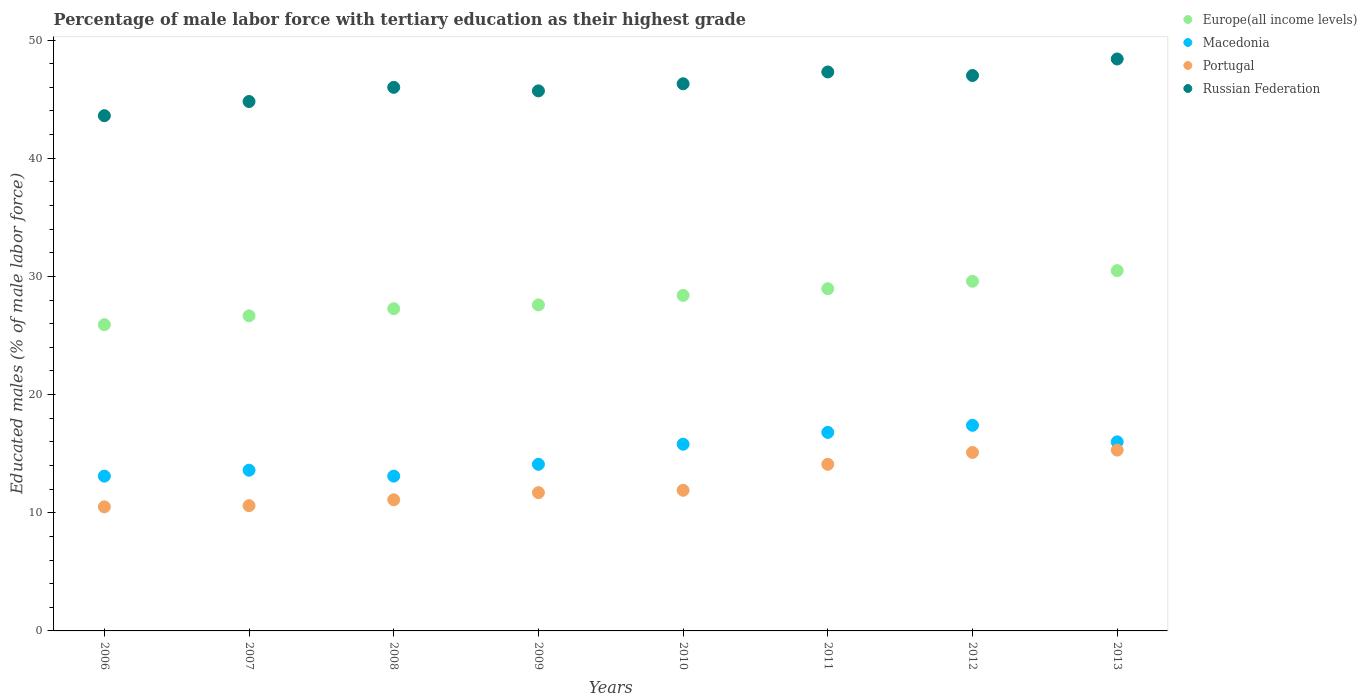What is the percentage of male labor force with tertiary education in Portugal in 2010?
Offer a very short reply. 11.9. Across all years, what is the maximum percentage of male labor force with tertiary education in Portugal?
Your response must be concise. 15.3. Across all years, what is the minimum percentage of male labor force with tertiary education in Europe(all income levels)?
Ensure brevity in your answer.  25.91. What is the total percentage of male labor force with tertiary education in Russian Federation in the graph?
Your answer should be very brief. 369.1. What is the difference between the percentage of male labor force with tertiary education in Europe(all income levels) in 2011 and the percentage of male labor force with tertiary education in Russian Federation in 2012?
Offer a very short reply. -18.04. What is the average percentage of male labor force with tertiary education in Europe(all income levels) per year?
Provide a succinct answer. 28.11. In the year 2010, what is the difference between the percentage of male labor force with tertiary education in Macedonia and percentage of male labor force with tertiary education in Portugal?
Offer a very short reply. 3.9. In how many years, is the percentage of male labor force with tertiary education in Europe(all income levels) greater than 10 %?
Provide a succinct answer. 8. What is the ratio of the percentage of male labor force with tertiary education in Russian Federation in 2006 to that in 2007?
Your response must be concise. 0.97. What is the difference between the highest and the second highest percentage of male labor force with tertiary education in Russian Federation?
Provide a succinct answer. 1.1. What is the difference between the highest and the lowest percentage of male labor force with tertiary education in Europe(all income levels)?
Provide a short and direct response. 4.58. Is the sum of the percentage of male labor force with tertiary education in Russian Federation in 2010 and 2011 greater than the maximum percentage of male labor force with tertiary education in Portugal across all years?
Provide a succinct answer. Yes. Is it the case that in every year, the sum of the percentage of male labor force with tertiary education in Macedonia and percentage of male labor force with tertiary education in Europe(all income levels)  is greater than the sum of percentage of male labor force with tertiary education in Portugal and percentage of male labor force with tertiary education in Russian Federation?
Provide a short and direct response. Yes. Is the percentage of male labor force with tertiary education in Russian Federation strictly less than the percentage of male labor force with tertiary education in Macedonia over the years?
Offer a very short reply. No. How many dotlines are there?
Offer a very short reply. 4. What is the difference between two consecutive major ticks on the Y-axis?
Provide a short and direct response. 10. Does the graph contain any zero values?
Keep it short and to the point. No. Where does the legend appear in the graph?
Ensure brevity in your answer.  Top right. What is the title of the graph?
Your answer should be compact. Percentage of male labor force with tertiary education as their highest grade. What is the label or title of the X-axis?
Provide a succinct answer. Years. What is the label or title of the Y-axis?
Give a very brief answer. Educated males (% of male labor force). What is the Educated males (% of male labor force) in Europe(all income levels) in 2006?
Offer a terse response. 25.91. What is the Educated males (% of male labor force) in Macedonia in 2006?
Make the answer very short. 13.1. What is the Educated males (% of male labor force) of Portugal in 2006?
Ensure brevity in your answer.  10.5. What is the Educated males (% of male labor force) of Russian Federation in 2006?
Your answer should be compact. 43.6. What is the Educated males (% of male labor force) of Europe(all income levels) in 2007?
Ensure brevity in your answer.  26.66. What is the Educated males (% of male labor force) of Macedonia in 2007?
Keep it short and to the point. 13.6. What is the Educated males (% of male labor force) in Portugal in 2007?
Provide a succinct answer. 10.6. What is the Educated males (% of male labor force) in Russian Federation in 2007?
Offer a terse response. 44.8. What is the Educated males (% of male labor force) in Europe(all income levels) in 2008?
Provide a succinct answer. 27.27. What is the Educated males (% of male labor force) of Macedonia in 2008?
Your answer should be very brief. 13.1. What is the Educated males (% of male labor force) of Portugal in 2008?
Your response must be concise. 11.1. What is the Educated males (% of male labor force) in Europe(all income levels) in 2009?
Keep it short and to the point. 27.59. What is the Educated males (% of male labor force) of Macedonia in 2009?
Provide a short and direct response. 14.1. What is the Educated males (% of male labor force) in Portugal in 2009?
Provide a short and direct response. 11.7. What is the Educated males (% of male labor force) of Russian Federation in 2009?
Offer a very short reply. 45.7. What is the Educated males (% of male labor force) of Europe(all income levels) in 2010?
Ensure brevity in your answer.  28.39. What is the Educated males (% of male labor force) in Macedonia in 2010?
Make the answer very short. 15.8. What is the Educated males (% of male labor force) of Portugal in 2010?
Make the answer very short. 11.9. What is the Educated males (% of male labor force) of Russian Federation in 2010?
Provide a short and direct response. 46.3. What is the Educated males (% of male labor force) in Europe(all income levels) in 2011?
Your answer should be very brief. 28.96. What is the Educated males (% of male labor force) in Macedonia in 2011?
Provide a succinct answer. 16.8. What is the Educated males (% of male labor force) in Portugal in 2011?
Your answer should be compact. 14.1. What is the Educated males (% of male labor force) in Russian Federation in 2011?
Give a very brief answer. 47.3. What is the Educated males (% of male labor force) of Europe(all income levels) in 2012?
Offer a terse response. 29.59. What is the Educated males (% of male labor force) in Macedonia in 2012?
Your answer should be compact. 17.4. What is the Educated males (% of male labor force) in Portugal in 2012?
Offer a very short reply. 15.1. What is the Educated males (% of male labor force) in Russian Federation in 2012?
Provide a short and direct response. 47. What is the Educated males (% of male labor force) in Europe(all income levels) in 2013?
Offer a terse response. 30.49. What is the Educated males (% of male labor force) in Macedonia in 2013?
Your response must be concise. 16. What is the Educated males (% of male labor force) of Portugal in 2013?
Your answer should be very brief. 15.3. What is the Educated males (% of male labor force) of Russian Federation in 2013?
Your answer should be compact. 48.4. Across all years, what is the maximum Educated males (% of male labor force) in Europe(all income levels)?
Your answer should be compact. 30.49. Across all years, what is the maximum Educated males (% of male labor force) in Macedonia?
Your response must be concise. 17.4. Across all years, what is the maximum Educated males (% of male labor force) of Portugal?
Make the answer very short. 15.3. Across all years, what is the maximum Educated males (% of male labor force) of Russian Federation?
Make the answer very short. 48.4. Across all years, what is the minimum Educated males (% of male labor force) in Europe(all income levels)?
Ensure brevity in your answer.  25.91. Across all years, what is the minimum Educated males (% of male labor force) of Macedonia?
Provide a short and direct response. 13.1. Across all years, what is the minimum Educated males (% of male labor force) in Russian Federation?
Offer a terse response. 43.6. What is the total Educated males (% of male labor force) of Europe(all income levels) in the graph?
Make the answer very short. 224.86. What is the total Educated males (% of male labor force) in Macedonia in the graph?
Your response must be concise. 119.9. What is the total Educated males (% of male labor force) of Portugal in the graph?
Ensure brevity in your answer.  100.3. What is the total Educated males (% of male labor force) in Russian Federation in the graph?
Your answer should be compact. 369.1. What is the difference between the Educated males (% of male labor force) of Europe(all income levels) in 2006 and that in 2007?
Your answer should be compact. -0.75. What is the difference between the Educated males (% of male labor force) of Portugal in 2006 and that in 2007?
Ensure brevity in your answer.  -0.1. What is the difference between the Educated males (% of male labor force) in Russian Federation in 2006 and that in 2007?
Your response must be concise. -1.2. What is the difference between the Educated males (% of male labor force) in Europe(all income levels) in 2006 and that in 2008?
Your answer should be very brief. -1.35. What is the difference between the Educated males (% of male labor force) of Macedonia in 2006 and that in 2008?
Provide a succinct answer. 0. What is the difference between the Educated males (% of male labor force) in Portugal in 2006 and that in 2008?
Your answer should be very brief. -0.6. What is the difference between the Educated males (% of male labor force) in Europe(all income levels) in 2006 and that in 2009?
Your answer should be very brief. -1.67. What is the difference between the Educated males (% of male labor force) of Macedonia in 2006 and that in 2009?
Offer a terse response. -1. What is the difference between the Educated males (% of male labor force) of Portugal in 2006 and that in 2009?
Your answer should be very brief. -1.2. What is the difference between the Educated males (% of male labor force) of Europe(all income levels) in 2006 and that in 2010?
Provide a succinct answer. -2.48. What is the difference between the Educated males (% of male labor force) of Macedonia in 2006 and that in 2010?
Your answer should be compact. -2.7. What is the difference between the Educated males (% of male labor force) in Portugal in 2006 and that in 2010?
Make the answer very short. -1.4. What is the difference between the Educated males (% of male labor force) in Europe(all income levels) in 2006 and that in 2011?
Provide a short and direct response. -3.04. What is the difference between the Educated males (% of male labor force) of Portugal in 2006 and that in 2011?
Provide a succinct answer. -3.6. What is the difference between the Educated males (% of male labor force) in Russian Federation in 2006 and that in 2011?
Provide a short and direct response. -3.7. What is the difference between the Educated males (% of male labor force) of Europe(all income levels) in 2006 and that in 2012?
Keep it short and to the point. -3.68. What is the difference between the Educated males (% of male labor force) in Macedonia in 2006 and that in 2012?
Provide a succinct answer. -4.3. What is the difference between the Educated males (% of male labor force) of Portugal in 2006 and that in 2012?
Your answer should be very brief. -4.6. What is the difference between the Educated males (% of male labor force) in Russian Federation in 2006 and that in 2012?
Your answer should be compact. -3.4. What is the difference between the Educated males (% of male labor force) in Europe(all income levels) in 2006 and that in 2013?
Give a very brief answer. -4.58. What is the difference between the Educated males (% of male labor force) in Macedonia in 2006 and that in 2013?
Keep it short and to the point. -2.9. What is the difference between the Educated males (% of male labor force) of Europe(all income levels) in 2007 and that in 2008?
Your answer should be compact. -0.6. What is the difference between the Educated males (% of male labor force) in Macedonia in 2007 and that in 2008?
Your response must be concise. 0.5. What is the difference between the Educated males (% of male labor force) in Europe(all income levels) in 2007 and that in 2009?
Ensure brevity in your answer.  -0.92. What is the difference between the Educated males (% of male labor force) in Macedonia in 2007 and that in 2009?
Your answer should be very brief. -0.5. What is the difference between the Educated males (% of male labor force) of Portugal in 2007 and that in 2009?
Offer a very short reply. -1.1. What is the difference between the Educated males (% of male labor force) in Europe(all income levels) in 2007 and that in 2010?
Ensure brevity in your answer.  -1.73. What is the difference between the Educated males (% of male labor force) in Macedonia in 2007 and that in 2010?
Your response must be concise. -2.2. What is the difference between the Educated males (% of male labor force) of Europe(all income levels) in 2007 and that in 2011?
Ensure brevity in your answer.  -2.29. What is the difference between the Educated males (% of male labor force) of Macedonia in 2007 and that in 2011?
Your answer should be compact. -3.2. What is the difference between the Educated males (% of male labor force) in Europe(all income levels) in 2007 and that in 2012?
Your answer should be very brief. -2.93. What is the difference between the Educated males (% of male labor force) of Macedonia in 2007 and that in 2012?
Provide a short and direct response. -3.8. What is the difference between the Educated males (% of male labor force) in Europe(all income levels) in 2007 and that in 2013?
Give a very brief answer. -3.82. What is the difference between the Educated males (% of male labor force) of Macedonia in 2007 and that in 2013?
Your answer should be very brief. -2.4. What is the difference between the Educated males (% of male labor force) in Europe(all income levels) in 2008 and that in 2009?
Provide a short and direct response. -0.32. What is the difference between the Educated males (% of male labor force) of Macedonia in 2008 and that in 2009?
Ensure brevity in your answer.  -1. What is the difference between the Educated males (% of male labor force) in Europe(all income levels) in 2008 and that in 2010?
Provide a succinct answer. -1.12. What is the difference between the Educated males (% of male labor force) in Europe(all income levels) in 2008 and that in 2011?
Provide a succinct answer. -1.69. What is the difference between the Educated males (% of male labor force) of Portugal in 2008 and that in 2011?
Your response must be concise. -3. What is the difference between the Educated males (% of male labor force) of Russian Federation in 2008 and that in 2011?
Offer a very short reply. -1.3. What is the difference between the Educated males (% of male labor force) in Europe(all income levels) in 2008 and that in 2012?
Ensure brevity in your answer.  -2.32. What is the difference between the Educated males (% of male labor force) of Macedonia in 2008 and that in 2012?
Your answer should be compact. -4.3. What is the difference between the Educated males (% of male labor force) of Russian Federation in 2008 and that in 2012?
Provide a short and direct response. -1. What is the difference between the Educated males (% of male labor force) in Europe(all income levels) in 2008 and that in 2013?
Make the answer very short. -3.22. What is the difference between the Educated males (% of male labor force) of Macedonia in 2008 and that in 2013?
Make the answer very short. -2.9. What is the difference between the Educated males (% of male labor force) in Portugal in 2008 and that in 2013?
Provide a short and direct response. -4.2. What is the difference between the Educated males (% of male labor force) of Europe(all income levels) in 2009 and that in 2010?
Give a very brief answer. -0.8. What is the difference between the Educated males (% of male labor force) of Macedonia in 2009 and that in 2010?
Provide a short and direct response. -1.7. What is the difference between the Educated males (% of male labor force) in Russian Federation in 2009 and that in 2010?
Provide a short and direct response. -0.6. What is the difference between the Educated males (% of male labor force) of Europe(all income levels) in 2009 and that in 2011?
Offer a very short reply. -1.37. What is the difference between the Educated males (% of male labor force) of Macedonia in 2009 and that in 2011?
Provide a succinct answer. -2.7. What is the difference between the Educated males (% of male labor force) of Europe(all income levels) in 2009 and that in 2012?
Make the answer very short. -2. What is the difference between the Educated males (% of male labor force) of Portugal in 2009 and that in 2012?
Keep it short and to the point. -3.4. What is the difference between the Educated males (% of male labor force) in Europe(all income levels) in 2009 and that in 2013?
Offer a terse response. -2.9. What is the difference between the Educated males (% of male labor force) in Europe(all income levels) in 2010 and that in 2011?
Your answer should be compact. -0.57. What is the difference between the Educated males (% of male labor force) of Portugal in 2010 and that in 2011?
Your answer should be compact. -2.2. What is the difference between the Educated males (% of male labor force) of Russian Federation in 2010 and that in 2011?
Your answer should be very brief. -1. What is the difference between the Educated males (% of male labor force) of Europe(all income levels) in 2010 and that in 2012?
Provide a succinct answer. -1.2. What is the difference between the Educated males (% of male labor force) of Russian Federation in 2010 and that in 2012?
Offer a very short reply. -0.7. What is the difference between the Educated males (% of male labor force) in Europe(all income levels) in 2010 and that in 2013?
Provide a succinct answer. -2.1. What is the difference between the Educated males (% of male labor force) of Portugal in 2010 and that in 2013?
Offer a terse response. -3.4. What is the difference between the Educated males (% of male labor force) of Europe(all income levels) in 2011 and that in 2012?
Give a very brief answer. -0.63. What is the difference between the Educated males (% of male labor force) of Portugal in 2011 and that in 2012?
Your answer should be very brief. -1. What is the difference between the Educated males (% of male labor force) of Europe(all income levels) in 2011 and that in 2013?
Provide a succinct answer. -1.53. What is the difference between the Educated males (% of male labor force) of Russian Federation in 2011 and that in 2013?
Your response must be concise. -1.1. What is the difference between the Educated males (% of male labor force) of Europe(all income levels) in 2012 and that in 2013?
Offer a terse response. -0.9. What is the difference between the Educated males (% of male labor force) of Macedonia in 2012 and that in 2013?
Your answer should be compact. 1.4. What is the difference between the Educated males (% of male labor force) of Portugal in 2012 and that in 2013?
Offer a terse response. -0.2. What is the difference between the Educated males (% of male labor force) in Europe(all income levels) in 2006 and the Educated males (% of male labor force) in Macedonia in 2007?
Ensure brevity in your answer.  12.31. What is the difference between the Educated males (% of male labor force) of Europe(all income levels) in 2006 and the Educated males (% of male labor force) of Portugal in 2007?
Keep it short and to the point. 15.31. What is the difference between the Educated males (% of male labor force) of Europe(all income levels) in 2006 and the Educated males (% of male labor force) of Russian Federation in 2007?
Your answer should be very brief. -18.89. What is the difference between the Educated males (% of male labor force) in Macedonia in 2006 and the Educated males (% of male labor force) in Portugal in 2007?
Keep it short and to the point. 2.5. What is the difference between the Educated males (% of male labor force) in Macedonia in 2006 and the Educated males (% of male labor force) in Russian Federation in 2007?
Provide a short and direct response. -31.7. What is the difference between the Educated males (% of male labor force) in Portugal in 2006 and the Educated males (% of male labor force) in Russian Federation in 2007?
Make the answer very short. -34.3. What is the difference between the Educated males (% of male labor force) of Europe(all income levels) in 2006 and the Educated males (% of male labor force) of Macedonia in 2008?
Give a very brief answer. 12.81. What is the difference between the Educated males (% of male labor force) of Europe(all income levels) in 2006 and the Educated males (% of male labor force) of Portugal in 2008?
Your response must be concise. 14.81. What is the difference between the Educated males (% of male labor force) of Europe(all income levels) in 2006 and the Educated males (% of male labor force) of Russian Federation in 2008?
Your answer should be compact. -20.09. What is the difference between the Educated males (% of male labor force) of Macedonia in 2006 and the Educated males (% of male labor force) of Russian Federation in 2008?
Give a very brief answer. -32.9. What is the difference between the Educated males (% of male labor force) of Portugal in 2006 and the Educated males (% of male labor force) of Russian Federation in 2008?
Your response must be concise. -35.5. What is the difference between the Educated males (% of male labor force) of Europe(all income levels) in 2006 and the Educated males (% of male labor force) of Macedonia in 2009?
Offer a terse response. 11.81. What is the difference between the Educated males (% of male labor force) in Europe(all income levels) in 2006 and the Educated males (% of male labor force) in Portugal in 2009?
Provide a succinct answer. 14.21. What is the difference between the Educated males (% of male labor force) in Europe(all income levels) in 2006 and the Educated males (% of male labor force) in Russian Federation in 2009?
Offer a very short reply. -19.79. What is the difference between the Educated males (% of male labor force) in Macedonia in 2006 and the Educated males (% of male labor force) in Russian Federation in 2009?
Make the answer very short. -32.6. What is the difference between the Educated males (% of male labor force) in Portugal in 2006 and the Educated males (% of male labor force) in Russian Federation in 2009?
Your response must be concise. -35.2. What is the difference between the Educated males (% of male labor force) of Europe(all income levels) in 2006 and the Educated males (% of male labor force) of Macedonia in 2010?
Provide a succinct answer. 10.11. What is the difference between the Educated males (% of male labor force) in Europe(all income levels) in 2006 and the Educated males (% of male labor force) in Portugal in 2010?
Make the answer very short. 14.01. What is the difference between the Educated males (% of male labor force) of Europe(all income levels) in 2006 and the Educated males (% of male labor force) of Russian Federation in 2010?
Your answer should be very brief. -20.39. What is the difference between the Educated males (% of male labor force) of Macedonia in 2006 and the Educated males (% of male labor force) of Russian Federation in 2010?
Ensure brevity in your answer.  -33.2. What is the difference between the Educated males (% of male labor force) of Portugal in 2006 and the Educated males (% of male labor force) of Russian Federation in 2010?
Your response must be concise. -35.8. What is the difference between the Educated males (% of male labor force) in Europe(all income levels) in 2006 and the Educated males (% of male labor force) in Macedonia in 2011?
Your response must be concise. 9.11. What is the difference between the Educated males (% of male labor force) of Europe(all income levels) in 2006 and the Educated males (% of male labor force) of Portugal in 2011?
Your response must be concise. 11.81. What is the difference between the Educated males (% of male labor force) in Europe(all income levels) in 2006 and the Educated males (% of male labor force) in Russian Federation in 2011?
Provide a short and direct response. -21.39. What is the difference between the Educated males (% of male labor force) in Macedonia in 2006 and the Educated males (% of male labor force) in Russian Federation in 2011?
Ensure brevity in your answer.  -34.2. What is the difference between the Educated males (% of male labor force) of Portugal in 2006 and the Educated males (% of male labor force) of Russian Federation in 2011?
Provide a succinct answer. -36.8. What is the difference between the Educated males (% of male labor force) of Europe(all income levels) in 2006 and the Educated males (% of male labor force) of Macedonia in 2012?
Your answer should be very brief. 8.51. What is the difference between the Educated males (% of male labor force) in Europe(all income levels) in 2006 and the Educated males (% of male labor force) in Portugal in 2012?
Ensure brevity in your answer.  10.81. What is the difference between the Educated males (% of male labor force) in Europe(all income levels) in 2006 and the Educated males (% of male labor force) in Russian Federation in 2012?
Keep it short and to the point. -21.09. What is the difference between the Educated males (% of male labor force) in Macedonia in 2006 and the Educated males (% of male labor force) in Portugal in 2012?
Offer a terse response. -2. What is the difference between the Educated males (% of male labor force) of Macedonia in 2006 and the Educated males (% of male labor force) of Russian Federation in 2012?
Offer a very short reply. -33.9. What is the difference between the Educated males (% of male labor force) of Portugal in 2006 and the Educated males (% of male labor force) of Russian Federation in 2012?
Provide a short and direct response. -36.5. What is the difference between the Educated males (% of male labor force) of Europe(all income levels) in 2006 and the Educated males (% of male labor force) of Macedonia in 2013?
Offer a very short reply. 9.91. What is the difference between the Educated males (% of male labor force) in Europe(all income levels) in 2006 and the Educated males (% of male labor force) in Portugal in 2013?
Your answer should be compact. 10.61. What is the difference between the Educated males (% of male labor force) in Europe(all income levels) in 2006 and the Educated males (% of male labor force) in Russian Federation in 2013?
Offer a very short reply. -22.49. What is the difference between the Educated males (% of male labor force) in Macedonia in 2006 and the Educated males (% of male labor force) in Russian Federation in 2013?
Your answer should be very brief. -35.3. What is the difference between the Educated males (% of male labor force) in Portugal in 2006 and the Educated males (% of male labor force) in Russian Federation in 2013?
Offer a terse response. -37.9. What is the difference between the Educated males (% of male labor force) of Europe(all income levels) in 2007 and the Educated males (% of male labor force) of Macedonia in 2008?
Your response must be concise. 13.56. What is the difference between the Educated males (% of male labor force) of Europe(all income levels) in 2007 and the Educated males (% of male labor force) of Portugal in 2008?
Provide a succinct answer. 15.56. What is the difference between the Educated males (% of male labor force) in Europe(all income levels) in 2007 and the Educated males (% of male labor force) in Russian Federation in 2008?
Your answer should be compact. -19.34. What is the difference between the Educated males (% of male labor force) of Macedonia in 2007 and the Educated males (% of male labor force) of Russian Federation in 2008?
Your response must be concise. -32.4. What is the difference between the Educated males (% of male labor force) of Portugal in 2007 and the Educated males (% of male labor force) of Russian Federation in 2008?
Offer a terse response. -35.4. What is the difference between the Educated males (% of male labor force) of Europe(all income levels) in 2007 and the Educated males (% of male labor force) of Macedonia in 2009?
Ensure brevity in your answer.  12.56. What is the difference between the Educated males (% of male labor force) of Europe(all income levels) in 2007 and the Educated males (% of male labor force) of Portugal in 2009?
Offer a terse response. 14.96. What is the difference between the Educated males (% of male labor force) of Europe(all income levels) in 2007 and the Educated males (% of male labor force) of Russian Federation in 2009?
Keep it short and to the point. -19.04. What is the difference between the Educated males (% of male labor force) of Macedonia in 2007 and the Educated males (% of male labor force) of Portugal in 2009?
Ensure brevity in your answer.  1.9. What is the difference between the Educated males (% of male labor force) in Macedonia in 2007 and the Educated males (% of male labor force) in Russian Federation in 2009?
Your answer should be very brief. -32.1. What is the difference between the Educated males (% of male labor force) in Portugal in 2007 and the Educated males (% of male labor force) in Russian Federation in 2009?
Make the answer very short. -35.1. What is the difference between the Educated males (% of male labor force) of Europe(all income levels) in 2007 and the Educated males (% of male labor force) of Macedonia in 2010?
Ensure brevity in your answer.  10.86. What is the difference between the Educated males (% of male labor force) in Europe(all income levels) in 2007 and the Educated males (% of male labor force) in Portugal in 2010?
Make the answer very short. 14.76. What is the difference between the Educated males (% of male labor force) in Europe(all income levels) in 2007 and the Educated males (% of male labor force) in Russian Federation in 2010?
Offer a very short reply. -19.64. What is the difference between the Educated males (% of male labor force) in Macedonia in 2007 and the Educated males (% of male labor force) in Russian Federation in 2010?
Provide a succinct answer. -32.7. What is the difference between the Educated males (% of male labor force) in Portugal in 2007 and the Educated males (% of male labor force) in Russian Federation in 2010?
Offer a terse response. -35.7. What is the difference between the Educated males (% of male labor force) in Europe(all income levels) in 2007 and the Educated males (% of male labor force) in Macedonia in 2011?
Give a very brief answer. 9.86. What is the difference between the Educated males (% of male labor force) in Europe(all income levels) in 2007 and the Educated males (% of male labor force) in Portugal in 2011?
Provide a succinct answer. 12.56. What is the difference between the Educated males (% of male labor force) of Europe(all income levels) in 2007 and the Educated males (% of male labor force) of Russian Federation in 2011?
Provide a succinct answer. -20.64. What is the difference between the Educated males (% of male labor force) of Macedonia in 2007 and the Educated males (% of male labor force) of Portugal in 2011?
Provide a short and direct response. -0.5. What is the difference between the Educated males (% of male labor force) of Macedonia in 2007 and the Educated males (% of male labor force) of Russian Federation in 2011?
Ensure brevity in your answer.  -33.7. What is the difference between the Educated males (% of male labor force) in Portugal in 2007 and the Educated males (% of male labor force) in Russian Federation in 2011?
Give a very brief answer. -36.7. What is the difference between the Educated males (% of male labor force) in Europe(all income levels) in 2007 and the Educated males (% of male labor force) in Macedonia in 2012?
Provide a short and direct response. 9.26. What is the difference between the Educated males (% of male labor force) of Europe(all income levels) in 2007 and the Educated males (% of male labor force) of Portugal in 2012?
Provide a succinct answer. 11.56. What is the difference between the Educated males (% of male labor force) of Europe(all income levels) in 2007 and the Educated males (% of male labor force) of Russian Federation in 2012?
Your answer should be very brief. -20.34. What is the difference between the Educated males (% of male labor force) in Macedonia in 2007 and the Educated males (% of male labor force) in Russian Federation in 2012?
Your answer should be very brief. -33.4. What is the difference between the Educated males (% of male labor force) in Portugal in 2007 and the Educated males (% of male labor force) in Russian Federation in 2012?
Your answer should be very brief. -36.4. What is the difference between the Educated males (% of male labor force) of Europe(all income levels) in 2007 and the Educated males (% of male labor force) of Macedonia in 2013?
Provide a short and direct response. 10.66. What is the difference between the Educated males (% of male labor force) in Europe(all income levels) in 2007 and the Educated males (% of male labor force) in Portugal in 2013?
Offer a very short reply. 11.36. What is the difference between the Educated males (% of male labor force) in Europe(all income levels) in 2007 and the Educated males (% of male labor force) in Russian Federation in 2013?
Keep it short and to the point. -21.74. What is the difference between the Educated males (% of male labor force) in Macedonia in 2007 and the Educated males (% of male labor force) in Portugal in 2013?
Your answer should be compact. -1.7. What is the difference between the Educated males (% of male labor force) in Macedonia in 2007 and the Educated males (% of male labor force) in Russian Federation in 2013?
Offer a terse response. -34.8. What is the difference between the Educated males (% of male labor force) in Portugal in 2007 and the Educated males (% of male labor force) in Russian Federation in 2013?
Give a very brief answer. -37.8. What is the difference between the Educated males (% of male labor force) of Europe(all income levels) in 2008 and the Educated males (% of male labor force) of Macedonia in 2009?
Keep it short and to the point. 13.17. What is the difference between the Educated males (% of male labor force) in Europe(all income levels) in 2008 and the Educated males (% of male labor force) in Portugal in 2009?
Offer a terse response. 15.57. What is the difference between the Educated males (% of male labor force) of Europe(all income levels) in 2008 and the Educated males (% of male labor force) of Russian Federation in 2009?
Give a very brief answer. -18.43. What is the difference between the Educated males (% of male labor force) in Macedonia in 2008 and the Educated males (% of male labor force) in Russian Federation in 2009?
Provide a succinct answer. -32.6. What is the difference between the Educated males (% of male labor force) of Portugal in 2008 and the Educated males (% of male labor force) of Russian Federation in 2009?
Provide a succinct answer. -34.6. What is the difference between the Educated males (% of male labor force) in Europe(all income levels) in 2008 and the Educated males (% of male labor force) in Macedonia in 2010?
Offer a terse response. 11.47. What is the difference between the Educated males (% of male labor force) in Europe(all income levels) in 2008 and the Educated males (% of male labor force) in Portugal in 2010?
Ensure brevity in your answer.  15.37. What is the difference between the Educated males (% of male labor force) in Europe(all income levels) in 2008 and the Educated males (% of male labor force) in Russian Federation in 2010?
Give a very brief answer. -19.03. What is the difference between the Educated males (% of male labor force) of Macedonia in 2008 and the Educated males (% of male labor force) of Portugal in 2010?
Offer a very short reply. 1.2. What is the difference between the Educated males (% of male labor force) of Macedonia in 2008 and the Educated males (% of male labor force) of Russian Federation in 2010?
Offer a very short reply. -33.2. What is the difference between the Educated males (% of male labor force) of Portugal in 2008 and the Educated males (% of male labor force) of Russian Federation in 2010?
Provide a succinct answer. -35.2. What is the difference between the Educated males (% of male labor force) of Europe(all income levels) in 2008 and the Educated males (% of male labor force) of Macedonia in 2011?
Your answer should be compact. 10.47. What is the difference between the Educated males (% of male labor force) of Europe(all income levels) in 2008 and the Educated males (% of male labor force) of Portugal in 2011?
Offer a very short reply. 13.17. What is the difference between the Educated males (% of male labor force) in Europe(all income levels) in 2008 and the Educated males (% of male labor force) in Russian Federation in 2011?
Your response must be concise. -20.03. What is the difference between the Educated males (% of male labor force) of Macedonia in 2008 and the Educated males (% of male labor force) of Portugal in 2011?
Your answer should be very brief. -1. What is the difference between the Educated males (% of male labor force) of Macedonia in 2008 and the Educated males (% of male labor force) of Russian Federation in 2011?
Provide a succinct answer. -34.2. What is the difference between the Educated males (% of male labor force) in Portugal in 2008 and the Educated males (% of male labor force) in Russian Federation in 2011?
Provide a short and direct response. -36.2. What is the difference between the Educated males (% of male labor force) in Europe(all income levels) in 2008 and the Educated males (% of male labor force) in Macedonia in 2012?
Offer a very short reply. 9.87. What is the difference between the Educated males (% of male labor force) of Europe(all income levels) in 2008 and the Educated males (% of male labor force) of Portugal in 2012?
Provide a succinct answer. 12.17. What is the difference between the Educated males (% of male labor force) of Europe(all income levels) in 2008 and the Educated males (% of male labor force) of Russian Federation in 2012?
Make the answer very short. -19.73. What is the difference between the Educated males (% of male labor force) of Macedonia in 2008 and the Educated males (% of male labor force) of Russian Federation in 2012?
Provide a succinct answer. -33.9. What is the difference between the Educated males (% of male labor force) of Portugal in 2008 and the Educated males (% of male labor force) of Russian Federation in 2012?
Give a very brief answer. -35.9. What is the difference between the Educated males (% of male labor force) in Europe(all income levels) in 2008 and the Educated males (% of male labor force) in Macedonia in 2013?
Make the answer very short. 11.27. What is the difference between the Educated males (% of male labor force) in Europe(all income levels) in 2008 and the Educated males (% of male labor force) in Portugal in 2013?
Make the answer very short. 11.97. What is the difference between the Educated males (% of male labor force) of Europe(all income levels) in 2008 and the Educated males (% of male labor force) of Russian Federation in 2013?
Your answer should be compact. -21.13. What is the difference between the Educated males (% of male labor force) of Macedonia in 2008 and the Educated males (% of male labor force) of Russian Federation in 2013?
Keep it short and to the point. -35.3. What is the difference between the Educated males (% of male labor force) of Portugal in 2008 and the Educated males (% of male labor force) of Russian Federation in 2013?
Provide a succinct answer. -37.3. What is the difference between the Educated males (% of male labor force) of Europe(all income levels) in 2009 and the Educated males (% of male labor force) of Macedonia in 2010?
Your answer should be very brief. 11.79. What is the difference between the Educated males (% of male labor force) in Europe(all income levels) in 2009 and the Educated males (% of male labor force) in Portugal in 2010?
Offer a terse response. 15.69. What is the difference between the Educated males (% of male labor force) in Europe(all income levels) in 2009 and the Educated males (% of male labor force) in Russian Federation in 2010?
Provide a succinct answer. -18.71. What is the difference between the Educated males (% of male labor force) in Macedonia in 2009 and the Educated males (% of male labor force) in Russian Federation in 2010?
Your answer should be compact. -32.2. What is the difference between the Educated males (% of male labor force) of Portugal in 2009 and the Educated males (% of male labor force) of Russian Federation in 2010?
Give a very brief answer. -34.6. What is the difference between the Educated males (% of male labor force) in Europe(all income levels) in 2009 and the Educated males (% of male labor force) in Macedonia in 2011?
Your answer should be very brief. 10.79. What is the difference between the Educated males (% of male labor force) in Europe(all income levels) in 2009 and the Educated males (% of male labor force) in Portugal in 2011?
Make the answer very short. 13.49. What is the difference between the Educated males (% of male labor force) in Europe(all income levels) in 2009 and the Educated males (% of male labor force) in Russian Federation in 2011?
Make the answer very short. -19.71. What is the difference between the Educated males (% of male labor force) in Macedonia in 2009 and the Educated males (% of male labor force) in Portugal in 2011?
Offer a terse response. 0. What is the difference between the Educated males (% of male labor force) in Macedonia in 2009 and the Educated males (% of male labor force) in Russian Federation in 2011?
Give a very brief answer. -33.2. What is the difference between the Educated males (% of male labor force) in Portugal in 2009 and the Educated males (% of male labor force) in Russian Federation in 2011?
Ensure brevity in your answer.  -35.6. What is the difference between the Educated males (% of male labor force) of Europe(all income levels) in 2009 and the Educated males (% of male labor force) of Macedonia in 2012?
Your answer should be compact. 10.19. What is the difference between the Educated males (% of male labor force) of Europe(all income levels) in 2009 and the Educated males (% of male labor force) of Portugal in 2012?
Your answer should be compact. 12.49. What is the difference between the Educated males (% of male labor force) in Europe(all income levels) in 2009 and the Educated males (% of male labor force) in Russian Federation in 2012?
Ensure brevity in your answer.  -19.41. What is the difference between the Educated males (% of male labor force) in Macedonia in 2009 and the Educated males (% of male labor force) in Portugal in 2012?
Make the answer very short. -1. What is the difference between the Educated males (% of male labor force) in Macedonia in 2009 and the Educated males (% of male labor force) in Russian Federation in 2012?
Offer a very short reply. -32.9. What is the difference between the Educated males (% of male labor force) of Portugal in 2009 and the Educated males (% of male labor force) of Russian Federation in 2012?
Offer a terse response. -35.3. What is the difference between the Educated males (% of male labor force) of Europe(all income levels) in 2009 and the Educated males (% of male labor force) of Macedonia in 2013?
Provide a succinct answer. 11.59. What is the difference between the Educated males (% of male labor force) of Europe(all income levels) in 2009 and the Educated males (% of male labor force) of Portugal in 2013?
Ensure brevity in your answer.  12.29. What is the difference between the Educated males (% of male labor force) in Europe(all income levels) in 2009 and the Educated males (% of male labor force) in Russian Federation in 2013?
Keep it short and to the point. -20.81. What is the difference between the Educated males (% of male labor force) of Macedonia in 2009 and the Educated males (% of male labor force) of Portugal in 2013?
Offer a terse response. -1.2. What is the difference between the Educated males (% of male labor force) in Macedonia in 2009 and the Educated males (% of male labor force) in Russian Federation in 2013?
Provide a succinct answer. -34.3. What is the difference between the Educated males (% of male labor force) in Portugal in 2009 and the Educated males (% of male labor force) in Russian Federation in 2013?
Your answer should be compact. -36.7. What is the difference between the Educated males (% of male labor force) of Europe(all income levels) in 2010 and the Educated males (% of male labor force) of Macedonia in 2011?
Your answer should be compact. 11.59. What is the difference between the Educated males (% of male labor force) of Europe(all income levels) in 2010 and the Educated males (% of male labor force) of Portugal in 2011?
Make the answer very short. 14.29. What is the difference between the Educated males (% of male labor force) of Europe(all income levels) in 2010 and the Educated males (% of male labor force) of Russian Federation in 2011?
Your response must be concise. -18.91. What is the difference between the Educated males (% of male labor force) in Macedonia in 2010 and the Educated males (% of male labor force) in Portugal in 2011?
Ensure brevity in your answer.  1.7. What is the difference between the Educated males (% of male labor force) of Macedonia in 2010 and the Educated males (% of male labor force) of Russian Federation in 2011?
Provide a short and direct response. -31.5. What is the difference between the Educated males (% of male labor force) in Portugal in 2010 and the Educated males (% of male labor force) in Russian Federation in 2011?
Provide a succinct answer. -35.4. What is the difference between the Educated males (% of male labor force) of Europe(all income levels) in 2010 and the Educated males (% of male labor force) of Macedonia in 2012?
Make the answer very short. 10.99. What is the difference between the Educated males (% of male labor force) of Europe(all income levels) in 2010 and the Educated males (% of male labor force) of Portugal in 2012?
Make the answer very short. 13.29. What is the difference between the Educated males (% of male labor force) of Europe(all income levels) in 2010 and the Educated males (% of male labor force) of Russian Federation in 2012?
Make the answer very short. -18.61. What is the difference between the Educated males (% of male labor force) of Macedonia in 2010 and the Educated males (% of male labor force) of Portugal in 2012?
Keep it short and to the point. 0.7. What is the difference between the Educated males (% of male labor force) of Macedonia in 2010 and the Educated males (% of male labor force) of Russian Federation in 2012?
Ensure brevity in your answer.  -31.2. What is the difference between the Educated males (% of male labor force) in Portugal in 2010 and the Educated males (% of male labor force) in Russian Federation in 2012?
Your answer should be compact. -35.1. What is the difference between the Educated males (% of male labor force) in Europe(all income levels) in 2010 and the Educated males (% of male labor force) in Macedonia in 2013?
Make the answer very short. 12.39. What is the difference between the Educated males (% of male labor force) in Europe(all income levels) in 2010 and the Educated males (% of male labor force) in Portugal in 2013?
Offer a very short reply. 13.09. What is the difference between the Educated males (% of male labor force) in Europe(all income levels) in 2010 and the Educated males (% of male labor force) in Russian Federation in 2013?
Provide a short and direct response. -20.01. What is the difference between the Educated males (% of male labor force) of Macedonia in 2010 and the Educated males (% of male labor force) of Russian Federation in 2013?
Ensure brevity in your answer.  -32.6. What is the difference between the Educated males (% of male labor force) of Portugal in 2010 and the Educated males (% of male labor force) of Russian Federation in 2013?
Offer a very short reply. -36.5. What is the difference between the Educated males (% of male labor force) in Europe(all income levels) in 2011 and the Educated males (% of male labor force) in Macedonia in 2012?
Keep it short and to the point. 11.56. What is the difference between the Educated males (% of male labor force) in Europe(all income levels) in 2011 and the Educated males (% of male labor force) in Portugal in 2012?
Your response must be concise. 13.86. What is the difference between the Educated males (% of male labor force) of Europe(all income levels) in 2011 and the Educated males (% of male labor force) of Russian Federation in 2012?
Make the answer very short. -18.04. What is the difference between the Educated males (% of male labor force) in Macedonia in 2011 and the Educated males (% of male labor force) in Russian Federation in 2012?
Your response must be concise. -30.2. What is the difference between the Educated males (% of male labor force) in Portugal in 2011 and the Educated males (% of male labor force) in Russian Federation in 2012?
Your answer should be compact. -32.9. What is the difference between the Educated males (% of male labor force) in Europe(all income levels) in 2011 and the Educated males (% of male labor force) in Macedonia in 2013?
Your response must be concise. 12.96. What is the difference between the Educated males (% of male labor force) in Europe(all income levels) in 2011 and the Educated males (% of male labor force) in Portugal in 2013?
Your answer should be compact. 13.66. What is the difference between the Educated males (% of male labor force) of Europe(all income levels) in 2011 and the Educated males (% of male labor force) of Russian Federation in 2013?
Provide a short and direct response. -19.44. What is the difference between the Educated males (% of male labor force) in Macedonia in 2011 and the Educated males (% of male labor force) in Portugal in 2013?
Make the answer very short. 1.5. What is the difference between the Educated males (% of male labor force) in Macedonia in 2011 and the Educated males (% of male labor force) in Russian Federation in 2013?
Keep it short and to the point. -31.6. What is the difference between the Educated males (% of male labor force) in Portugal in 2011 and the Educated males (% of male labor force) in Russian Federation in 2013?
Offer a terse response. -34.3. What is the difference between the Educated males (% of male labor force) of Europe(all income levels) in 2012 and the Educated males (% of male labor force) of Macedonia in 2013?
Provide a succinct answer. 13.59. What is the difference between the Educated males (% of male labor force) in Europe(all income levels) in 2012 and the Educated males (% of male labor force) in Portugal in 2013?
Your response must be concise. 14.29. What is the difference between the Educated males (% of male labor force) in Europe(all income levels) in 2012 and the Educated males (% of male labor force) in Russian Federation in 2013?
Offer a very short reply. -18.81. What is the difference between the Educated males (% of male labor force) of Macedonia in 2012 and the Educated males (% of male labor force) of Portugal in 2013?
Offer a terse response. 2.1. What is the difference between the Educated males (% of male labor force) of Macedonia in 2012 and the Educated males (% of male labor force) of Russian Federation in 2013?
Give a very brief answer. -31. What is the difference between the Educated males (% of male labor force) of Portugal in 2012 and the Educated males (% of male labor force) of Russian Federation in 2013?
Give a very brief answer. -33.3. What is the average Educated males (% of male labor force) of Europe(all income levels) per year?
Ensure brevity in your answer.  28.11. What is the average Educated males (% of male labor force) of Macedonia per year?
Offer a very short reply. 14.99. What is the average Educated males (% of male labor force) in Portugal per year?
Your response must be concise. 12.54. What is the average Educated males (% of male labor force) in Russian Federation per year?
Keep it short and to the point. 46.14. In the year 2006, what is the difference between the Educated males (% of male labor force) of Europe(all income levels) and Educated males (% of male labor force) of Macedonia?
Your response must be concise. 12.81. In the year 2006, what is the difference between the Educated males (% of male labor force) in Europe(all income levels) and Educated males (% of male labor force) in Portugal?
Provide a short and direct response. 15.41. In the year 2006, what is the difference between the Educated males (% of male labor force) in Europe(all income levels) and Educated males (% of male labor force) in Russian Federation?
Keep it short and to the point. -17.69. In the year 2006, what is the difference between the Educated males (% of male labor force) in Macedonia and Educated males (% of male labor force) in Portugal?
Offer a terse response. 2.6. In the year 2006, what is the difference between the Educated males (% of male labor force) of Macedonia and Educated males (% of male labor force) of Russian Federation?
Ensure brevity in your answer.  -30.5. In the year 2006, what is the difference between the Educated males (% of male labor force) in Portugal and Educated males (% of male labor force) in Russian Federation?
Ensure brevity in your answer.  -33.1. In the year 2007, what is the difference between the Educated males (% of male labor force) of Europe(all income levels) and Educated males (% of male labor force) of Macedonia?
Offer a very short reply. 13.06. In the year 2007, what is the difference between the Educated males (% of male labor force) of Europe(all income levels) and Educated males (% of male labor force) of Portugal?
Offer a terse response. 16.06. In the year 2007, what is the difference between the Educated males (% of male labor force) of Europe(all income levels) and Educated males (% of male labor force) of Russian Federation?
Make the answer very short. -18.14. In the year 2007, what is the difference between the Educated males (% of male labor force) of Macedonia and Educated males (% of male labor force) of Russian Federation?
Make the answer very short. -31.2. In the year 2007, what is the difference between the Educated males (% of male labor force) of Portugal and Educated males (% of male labor force) of Russian Federation?
Provide a succinct answer. -34.2. In the year 2008, what is the difference between the Educated males (% of male labor force) in Europe(all income levels) and Educated males (% of male labor force) in Macedonia?
Your answer should be compact. 14.17. In the year 2008, what is the difference between the Educated males (% of male labor force) in Europe(all income levels) and Educated males (% of male labor force) in Portugal?
Keep it short and to the point. 16.17. In the year 2008, what is the difference between the Educated males (% of male labor force) of Europe(all income levels) and Educated males (% of male labor force) of Russian Federation?
Offer a terse response. -18.73. In the year 2008, what is the difference between the Educated males (% of male labor force) of Macedonia and Educated males (% of male labor force) of Portugal?
Provide a succinct answer. 2. In the year 2008, what is the difference between the Educated males (% of male labor force) of Macedonia and Educated males (% of male labor force) of Russian Federation?
Your answer should be very brief. -32.9. In the year 2008, what is the difference between the Educated males (% of male labor force) of Portugal and Educated males (% of male labor force) of Russian Federation?
Provide a succinct answer. -34.9. In the year 2009, what is the difference between the Educated males (% of male labor force) in Europe(all income levels) and Educated males (% of male labor force) in Macedonia?
Give a very brief answer. 13.49. In the year 2009, what is the difference between the Educated males (% of male labor force) of Europe(all income levels) and Educated males (% of male labor force) of Portugal?
Your response must be concise. 15.89. In the year 2009, what is the difference between the Educated males (% of male labor force) in Europe(all income levels) and Educated males (% of male labor force) in Russian Federation?
Provide a short and direct response. -18.11. In the year 2009, what is the difference between the Educated males (% of male labor force) of Macedonia and Educated males (% of male labor force) of Russian Federation?
Your answer should be compact. -31.6. In the year 2009, what is the difference between the Educated males (% of male labor force) of Portugal and Educated males (% of male labor force) of Russian Federation?
Ensure brevity in your answer.  -34. In the year 2010, what is the difference between the Educated males (% of male labor force) in Europe(all income levels) and Educated males (% of male labor force) in Macedonia?
Your answer should be compact. 12.59. In the year 2010, what is the difference between the Educated males (% of male labor force) in Europe(all income levels) and Educated males (% of male labor force) in Portugal?
Your answer should be very brief. 16.49. In the year 2010, what is the difference between the Educated males (% of male labor force) in Europe(all income levels) and Educated males (% of male labor force) in Russian Federation?
Keep it short and to the point. -17.91. In the year 2010, what is the difference between the Educated males (% of male labor force) of Macedonia and Educated males (% of male labor force) of Russian Federation?
Your answer should be compact. -30.5. In the year 2010, what is the difference between the Educated males (% of male labor force) of Portugal and Educated males (% of male labor force) of Russian Federation?
Offer a very short reply. -34.4. In the year 2011, what is the difference between the Educated males (% of male labor force) of Europe(all income levels) and Educated males (% of male labor force) of Macedonia?
Give a very brief answer. 12.16. In the year 2011, what is the difference between the Educated males (% of male labor force) of Europe(all income levels) and Educated males (% of male labor force) of Portugal?
Make the answer very short. 14.86. In the year 2011, what is the difference between the Educated males (% of male labor force) of Europe(all income levels) and Educated males (% of male labor force) of Russian Federation?
Keep it short and to the point. -18.34. In the year 2011, what is the difference between the Educated males (% of male labor force) in Macedonia and Educated males (% of male labor force) in Portugal?
Your response must be concise. 2.7. In the year 2011, what is the difference between the Educated males (% of male labor force) in Macedonia and Educated males (% of male labor force) in Russian Federation?
Make the answer very short. -30.5. In the year 2011, what is the difference between the Educated males (% of male labor force) of Portugal and Educated males (% of male labor force) of Russian Federation?
Your answer should be very brief. -33.2. In the year 2012, what is the difference between the Educated males (% of male labor force) of Europe(all income levels) and Educated males (% of male labor force) of Macedonia?
Give a very brief answer. 12.19. In the year 2012, what is the difference between the Educated males (% of male labor force) of Europe(all income levels) and Educated males (% of male labor force) of Portugal?
Make the answer very short. 14.49. In the year 2012, what is the difference between the Educated males (% of male labor force) of Europe(all income levels) and Educated males (% of male labor force) of Russian Federation?
Keep it short and to the point. -17.41. In the year 2012, what is the difference between the Educated males (% of male labor force) of Macedonia and Educated males (% of male labor force) of Portugal?
Offer a very short reply. 2.3. In the year 2012, what is the difference between the Educated males (% of male labor force) of Macedonia and Educated males (% of male labor force) of Russian Federation?
Give a very brief answer. -29.6. In the year 2012, what is the difference between the Educated males (% of male labor force) in Portugal and Educated males (% of male labor force) in Russian Federation?
Give a very brief answer. -31.9. In the year 2013, what is the difference between the Educated males (% of male labor force) in Europe(all income levels) and Educated males (% of male labor force) in Macedonia?
Your response must be concise. 14.49. In the year 2013, what is the difference between the Educated males (% of male labor force) in Europe(all income levels) and Educated males (% of male labor force) in Portugal?
Your answer should be very brief. 15.19. In the year 2013, what is the difference between the Educated males (% of male labor force) in Europe(all income levels) and Educated males (% of male labor force) in Russian Federation?
Provide a short and direct response. -17.91. In the year 2013, what is the difference between the Educated males (% of male labor force) of Macedonia and Educated males (% of male labor force) of Portugal?
Keep it short and to the point. 0.7. In the year 2013, what is the difference between the Educated males (% of male labor force) of Macedonia and Educated males (% of male labor force) of Russian Federation?
Provide a succinct answer. -32.4. In the year 2013, what is the difference between the Educated males (% of male labor force) of Portugal and Educated males (% of male labor force) of Russian Federation?
Give a very brief answer. -33.1. What is the ratio of the Educated males (% of male labor force) in Europe(all income levels) in 2006 to that in 2007?
Your response must be concise. 0.97. What is the ratio of the Educated males (% of male labor force) of Macedonia in 2006 to that in 2007?
Your answer should be compact. 0.96. What is the ratio of the Educated males (% of male labor force) in Portugal in 2006 to that in 2007?
Your answer should be very brief. 0.99. What is the ratio of the Educated males (% of male labor force) of Russian Federation in 2006 to that in 2007?
Your response must be concise. 0.97. What is the ratio of the Educated males (% of male labor force) in Europe(all income levels) in 2006 to that in 2008?
Provide a succinct answer. 0.95. What is the ratio of the Educated males (% of male labor force) in Portugal in 2006 to that in 2008?
Make the answer very short. 0.95. What is the ratio of the Educated males (% of male labor force) of Russian Federation in 2006 to that in 2008?
Your answer should be compact. 0.95. What is the ratio of the Educated males (% of male labor force) in Europe(all income levels) in 2006 to that in 2009?
Your answer should be compact. 0.94. What is the ratio of the Educated males (% of male labor force) in Macedonia in 2006 to that in 2009?
Provide a short and direct response. 0.93. What is the ratio of the Educated males (% of male labor force) in Portugal in 2006 to that in 2009?
Your answer should be compact. 0.9. What is the ratio of the Educated males (% of male labor force) of Russian Federation in 2006 to that in 2009?
Keep it short and to the point. 0.95. What is the ratio of the Educated males (% of male labor force) of Europe(all income levels) in 2006 to that in 2010?
Ensure brevity in your answer.  0.91. What is the ratio of the Educated males (% of male labor force) in Macedonia in 2006 to that in 2010?
Give a very brief answer. 0.83. What is the ratio of the Educated males (% of male labor force) in Portugal in 2006 to that in 2010?
Give a very brief answer. 0.88. What is the ratio of the Educated males (% of male labor force) of Russian Federation in 2006 to that in 2010?
Offer a terse response. 0.94. What is the ratio of the Educated males (% of male labor force) in Europe(all income levels) in 2006 to that in 2011?
Keep it short and to the point. 0.89. What is the ratio of the Educated males (% of male labor force) of Macedonia in 2006 to that in 2011?
Your answer should be very brief. 0.78. What is the ratio of the Educated males (% of male labor force) of Portugal in 2006 to that in 2011?
Offer a terse response. 0.74. What is the ratio of the Educated males (% of male labor force) in Russian Federation in 2006 to that in 2011?
Your response must be concise. 0.92. What is the ratio of the Educated males (% of male labor force) in Europe(all income levels) in 2006 to that in 2012?
Make the answer very short. 0.88. What is the ratio of the Educated males (% of male labor force) in Macedonia in 2006 to that in 2012?
Keep it short and to the point. 0.75. What is the ratio of the Educated males (% of male labor force) of Portugal in 2006 to that in 2012?
Provide a succinct answer. 0.7. What is the ratio of the Educated males (% of male labor force) in Russian Federation in 2006 to that in 2012?
Keep it short and to the point. 0.93. What is the ratio of the Educated males (% of male labor force) of Europe(all income levels) in 2006 to that in 2013?
Your answer should be compact. 0.85. What is the ratio of the Educated males (% of male labor force) in Macedonia in 2006 to that in 2013?
Make the answer very short. 0.82. What is the ratio of the Educated males (% of male labor force) in Portugal in 2006 to that in 2013?
Provide a succinct answer. 0.69. What is the ratio of the Educated males (% of male labor force) of Russian Federation in 2006 to that in 2013?
Make the answer very short. 0.9. What is the ratio of the Educated males (% of male labor force) of Europe(all income levels) in 2007 to that in 2008?
Keep it short and to the point. 0.98. What is the ratio of the Educated males (% of male labor force) of Macedonia in 2007 to that in 2008?
Your answer should be compact. 1.04. What is the ratio of the Educated males (% of male labor force) in Portugal in 2007 to that in 2008?
Offer a terse response. 0.95. What is the ratio of the Educated males (% of male labor force) in Russian Federation in 2007 to that in 2008?
Keep it short and to the point. 0.97. What is the ratio of the Educated males (% of male labor force) of Europe(all income levels) in 2007 to that in 2009?
Your answer should be very brief. 0.97. What is the ratio of the Educated males (% of male labor force) of Macedonia in 2007 to that in 2009?
Provide a short and direct response. 0.96. What is the ratio of the Educated males (% of male labor force) of Portugal in 2007 to that in 2009?
Ensure brevity in your answer.  0.91. What is the ratio of the Educated males (% of male labor force) in Russian Federation in 2007 to that in 2009?
Provide a short and direct response. 0.98. What is the ratio of the Educated males (% of male labor force) of Europe(all income levels) in 2007 to that in 2010?
Offer a terse response. 0.94. What is the ratio of the Educated males (% of male labor force) of Macedonia in 2007 to that in 2010?
Your response must be concise. 0.86. What is the ratio of the Educated males (% of male labor force) of Portugal in 2007 to that in 2010?
Ensure brevity in your answer.  0.89. What is the ratio of the Educated males (% of male labor force) of Russian Federation in 2007 to that in 2010?
Your answer should be very brief. 0.97. What is the ratio of the Educated males (% of male labor force) of Europe(all income levels) in 2007 to that in 2011?
Keep it short and to the point. 0.92. What is the ratio of the Educated males (% of male labor force) in Macedonia in 2007 to that in 2011?
Provide a succinct answer. 0.81. What is the ratio of the Educated males (% of male labor force) in Portugal in 2007 to that in 2011?
Your answer should be compact. 0.75. What is the ratio of the Educated males (% of male labor force) in Russian Federation in 2007 to that in 2011?
Provide a succinct answer. 0.95. What is the ratio of the Educated males (% of male labor force) of Europe(all income levels) in 2007 to that in 2012?
Keep it short and to the point. 0.9. What is the ratio of the Educated males (% of male labor force) of Macedonia in 2007 to that in 2012?
Give a very brief answer. 0.78. What is the ratio of the Educated males (% of male labor force) in Portugal in 2007 to that in 2012?
Make the answer very short. 0.7. What is the ratio of the Educated males (% of male labor force) of Russian Federation in 2007 to that in 2012?
Your answer should be compact. 0.95. What is the ratio of the Educated males (% of male labor force) in Europe(all income levels) in 2007 to that in 2013?
Offer a very short reply. 0.87. What is the ratio of the Educated males (% of male labor force) in Portugal in 2007 to that in 2013?
Make the answer very short. 0.69. What is the ratio of the Educated males (% of male labor force) in Russian Federation in 2007 to that in 2013?
Your response must be concise. 0.93. What is the ratio of the Educated males (% of male labor force) in Europe(all income levels) in 2008 to that in 2009?
Make the answer very short. 0.99. What is the ratio of the Educated males (% of male labor force) in Macedonia in 2008 to that in 2009?
Offer a very short reply. 0.93. What is the ratio of the Educated males (% of male labor force) in Portugal in 2008 to that in 2009?
Your answer should be very brief. 0.95. What is the ratio of the Educated males (% of male labor force) of Russian Federation in 2008 to that in 2009?
Your answer should be compact. 1.01. What is the ratio of the Educated males (% of male labor force) of Europe(all income levels) in 2008 to that in 2010?
Provide a short and direct response. 0.96. What is the ratio of the Educated males (% of male labor force) of Macedonia in 2008 to that in 2010?
Keep it short and to the point. 0.83. What is the ratio of the Educated males (% of male labor force) in Portugal in 2008 to that in 2010?
Your answer should be compact. 0.93. What is the ratio of the Educated males (% of male labor force) of Europe(all income levels) in 2008 to that in 2011?
Make the answer very short. 0.94. What is the ratio of the Educated males (% of male labor force) of Macedonia in 2008 to that in 2011?
Ensure brevity in your answer.  0.78. What is the ratio of the Educated males (% of male labor force) in Portugal in 2008 to that in 2011?
Keep it short and to the point. 0.79. What is the ratio of the Educated males (% of male labor force) of Russian Federation in 2008 to that in 2011?
Give a very brief answer. 0.97. What is the ratio of the Educated males (% of male labor force) in Europe(all income levels) in 2008 to that in 2012?
Give a very brief answer. 0.92. What is the ratio of the Educated males (% of male labor force) of Macedonia in 2008 to that in 2012?
Offer a terse response. 0.75. What is the ratio of the Educated males (% of male labor force) of Portugal in 2008 to that in 2012?
Ensure brevity in your answer.  0.74. What is the ratio of the Educated males (% of male labor force) in Russian Federation in 2008 to that in 2012?
Provide a short and direct response. 0.98. What is the ratio of the Educated males (% of male labor force) in Europe(all income levels) in 2008 to that in 2013?
Provide a succinct answer. 0.89. What is the ratio of the Educated males (% of male labor force) of Macedonia in 2008 to that in 2013?
Ensure brevity in your answer.  0.82. What is the ratio of the Educated males (% of male labor force) in Portugal in 2008 to that in 2013?
Your answer should be very brief. 0.73. What is the ratio of the Educated males (% of male labor force) of Russian Federation in 2008 to that in 2013?
Ensure brevity in your answer.  0.95. What is the ratio of the Educated males (% of male labor force) of Europe(all income levels) in 2009 to that in 2010?
Offer a terse response. 0.97. What is the ratio of the Educated males (% of male labor force) in Macedonia in 2009 to that in 2010?
Ensure brevity in your answer.  0.89. What is the ratio of the Educated males (% of male labor force) in Portugal in 2009 to that in 2010?
Your response must be concise. 0.98. What is the ratio of the Educated males (% of male labor force) in Russian Federation in 2009 to that in 2010?
Provide a succinct answer. 0.99. What is the ratio of the Educated males (% of male labor force) of Europe(all income levels) in 2009 to that in 2011?
Offer a very short reply. 0.95. What is the ratio of the Educated males (% of male labor force) in Macedonia in 2009 to that in 2011?
Give a very brief answer. 0.84. What is the ratio of the Educated males (% of male labor force) in Portugal in 2009 to that in 2011?
Your response must be concise. 0.83. What is the ratio of the Educated males (% of male labor force) of Russian Federation in 2009 to that in 2011?
Your answer should be compact. 0.97. What is the ratio of the Educated males (% of male labor force) of Europe(all income levels) in 2009 to that in 2012?
Offer a very short reply. 0.93. What is the ratio of the Educated males (% of male labor force) of Macedonia in 2009 to that in 2012?
Provide a short and direct response. 0.81. What is the ratio of the Educated males (% of male labor force) of Portugal in 2009 to that in 2012?
Offer a very short reply. 0.77. What is the ratio of the Educated males (% of male labor force) of Russian Federation in 2009 to that in 2012?
Provide a short and direct response. 0.97. What is the ratio of the Educated males (% of male labor force) of Europe(all income levels) in 2009 to that in 2013?
Provide a succinct answer. 0.9. What is the ratio of the Educated males (% of male labor force) of Macedonia in 2009 to that in 2013?
Your answer should be compact. 0.88. What is the ratio of the Educated males (% of male labor force) of Portugal in 2009 to that in 2013?
Your answer should be very brief. 0.76. What is the ratio of the Educated males (% of male labor force) of Russian Federation in 2009 to that in 2013?
Your answer should be compact. 0.94. What is the ratio of the Educated males (% of male labor force) of Europe(all income levels) in 2010 to that in 2011?
Provide a succinct answer. 0.98. What is the ratio of the Educated males (% of male labor force) of Macedonia in 2010 to that in 2011?
Your response must be concise. 0.94. What is the ratio of the Educated males (% of male labor force) of Portugal in 2010 to that in 2011?
Your answer should be compact. 0.84. What is the ratio of the Educated males (% of male labor force) in Russian Federation in 2010 to that in 2011?
Ensure brevity in your answer.  0.98. What is the ratio of the Educated males (% of male labor force) of Europe(all income levels) in 2010 to that in 2012?
Ensure brevity in your answer.  0.96. What is the ratio of the Educated males (% of male labor force) in Macedonia in 2010 to that in 2012?
Make the answer very short. 0.91. What is the ratio of the Educated males (% of male labor force) of Portugal in 2010 to that in 2012?
Ensure brevity in your answer.  0.79. What is the ratio of the Educated males (% of male labor force) in Russian Federation in 2010 to that in 2012?
Provide a short and direct response. 0.99. What is the ratio of the Educated males (% of male labor force) of Europe(all income levels) in 2010 to that in 2013?
Give a very brief answer. 0.93. What is the ratio of the Educated males (% of male labor force) of Macedonia in 2010 to that in 2013?
Provide a short and direct response. 0.99. What is the ratio of the Educated males (% of male labor force) in Portugal in 2010 to that in 2013?
Offer a very short reply. 0.78. What is the ratio of the Educated males (% of male labor force) in Russian Federation in 2010 to that in 2013?
Provide a short and direct response. 0.96. What is the ratio of the Educated males (% of male labor force) of Europe(all income levels) in 2011 to that in 2012?
Offer a very short reply. 0.98. What is the ratio of the Educated males (% of male labor force) in Macedonia in 2011 to that in 2012?
Keep it short and to the point. 0.97. What is the ratio of the Educated males (% of male labor force) of Portugal in 2011 to that in 2012?
Provide a succinct answer. 0.93. What is the ratio of the Educated males (% of male labor force) of Russian Federation in 2011 to that in 2012?
Give a very brief answer. 1.01. What is the ratio of the Educated males (% of male labor force) in Europe(all income levels) in 2011 to that in 2013?
Offer a terse response. 0.95. What is the ratio of the Educated males (% of male labor force) in Portugal in 2011 to that in 2013?
Your response must be concise. 0.92. What is the ratio of the Educated males (% of male labor force) in Russian Federation in 2011 to that in 2013?
Provide a short and direct response. 0.98. What is the ratio of the Educated males (% of male labor force) in Europe(all income levels) in 2012 to that in 2013?
Provide a short and direct response. 0.97. What is the ratio of the Educated males (% of male labor force) in Macedonia in 2012 to that in 2013?
Your answer should be very brief. 1.09. What is the ratio of the Educated males (% of male labor force) of Portugal in 2012 to that in 2013?
Ensure brevity in your answer.  0.99. What is the ratio of the Educated males (% of male labor force) in Russian Federation in 2012 to that in 2013?
Offer a very short reply. 0.97. What is the difference between the highest and the second highest Educated males (% of male labor force) of Europe(all income levels)?
Your answer should be very brief. 0.9. What is the difference between the highest and the second highest Educated males (% of male labor force) in Macedonia?
Make the answer very short. 0.6. What is the difference between the highest and the second highest Educated males (% of male labor force) in Portugal?
Your answer should be compact. 0.2. What is the difference between the highest and the second highest Educated males (% of male labor force) in Russian Federation?
Give a very brief answer. 1.1. What is the difference between the highest and the lowest Educated males (% of male labor force) in Europe(all income levels)?
Offer a terse response. 4.58. What is the difference between the highest and the lowest Educated males (% of male labor force) of Macedonia?
Your answer should be very brief. 4.3. What is the difference between the highest and the lowest Educated males (% of male labor force) of Portugal?
Your answer should be compact. 4.8. 